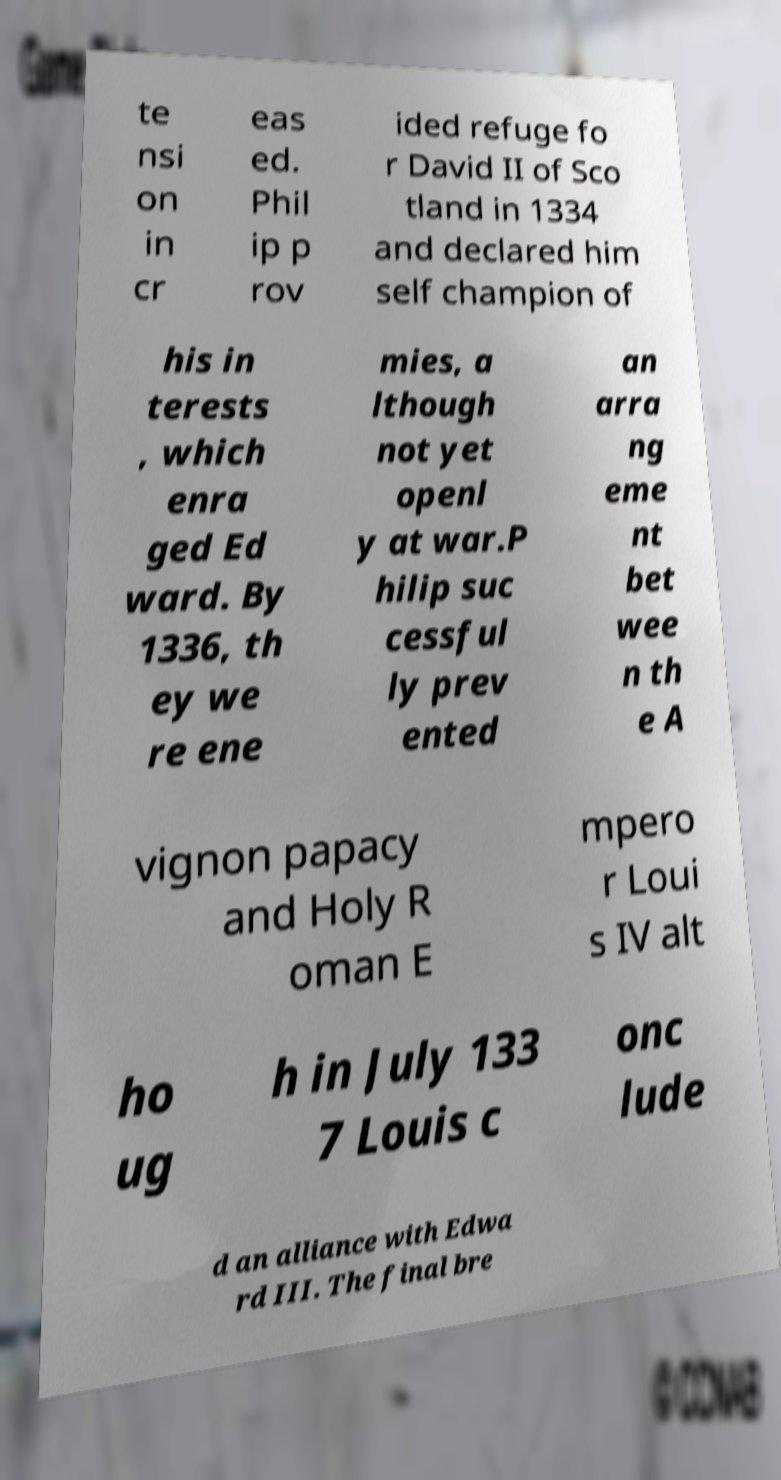Please read and relay the text visible in this image. What does it say? te nsi on in cr eas ed. Phil ip p rov ided refuge fo r David II of Sco tland in 1334 and declared him self champion of his in terests , which enra ged Ed ward. By 1336, th ey we re ene mies, a lthough not yet openl y at war.P hilip suc cessful ly prev ented an arra ng eme nt bet wee n th e A vignon papacy and Holy R oman E mpero r Loui s IV alt ho ug h in July 133 7 Louis c onc lude d an alliance with Edwa rd III. The final bre 